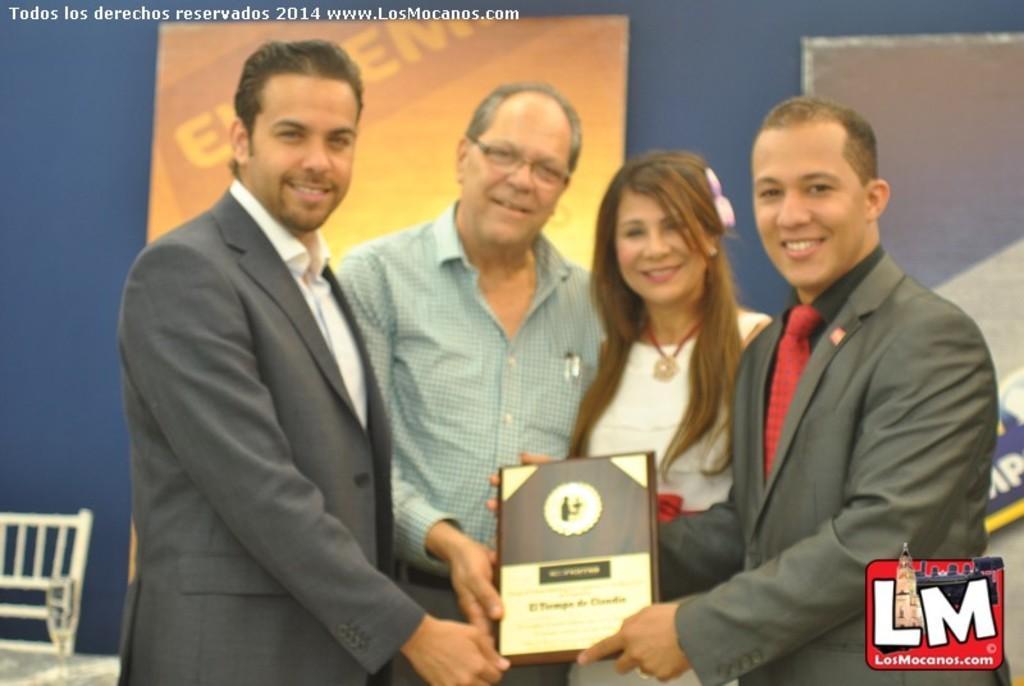In one or two sentences, can you explain what this image depicts? In this picture there are four people standing and holding a frame. In the background of the image we can see boards on the wall, chair and glass on the table. In the bottom right side of the image we can see logo. In the top left side of the image we can see text. 